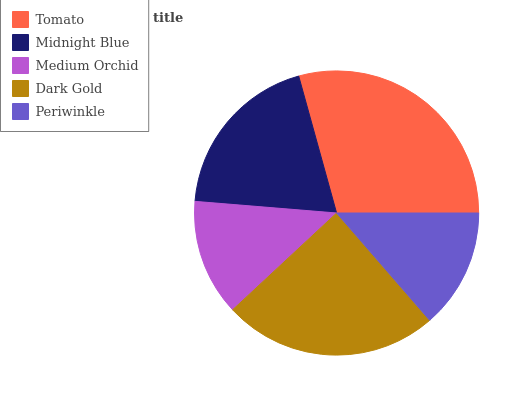Is Medium Orchid the minimum?
Answer yes or no. Yes. Is Tomato the maximum?
Answer yes or no. Yes. Is Midnight Blue the minimum?
Answer yes or no. No. Is Midnight Blue the maximum?
Answer yes or no. No. Is Tomato greater than Midnight Blue?
Answer yes or no. Yes. Is Midnight Blue less than Tomato?
Answer yes or no. Yes. Is Midnight Blue greater than Tomato?
Answer yes or no. No. Is Tomato less than Midnight Blue?
Answer yes or no. No. Is Midnight Blue the high median?
Answer yes or no. Yes. Is Midnight Blue the low median?
Answer yes or no. Yes. Is Tomato the high median?
Answer yes or no. No. Is Periwinkle the low median?
Answer yes or no. No. 